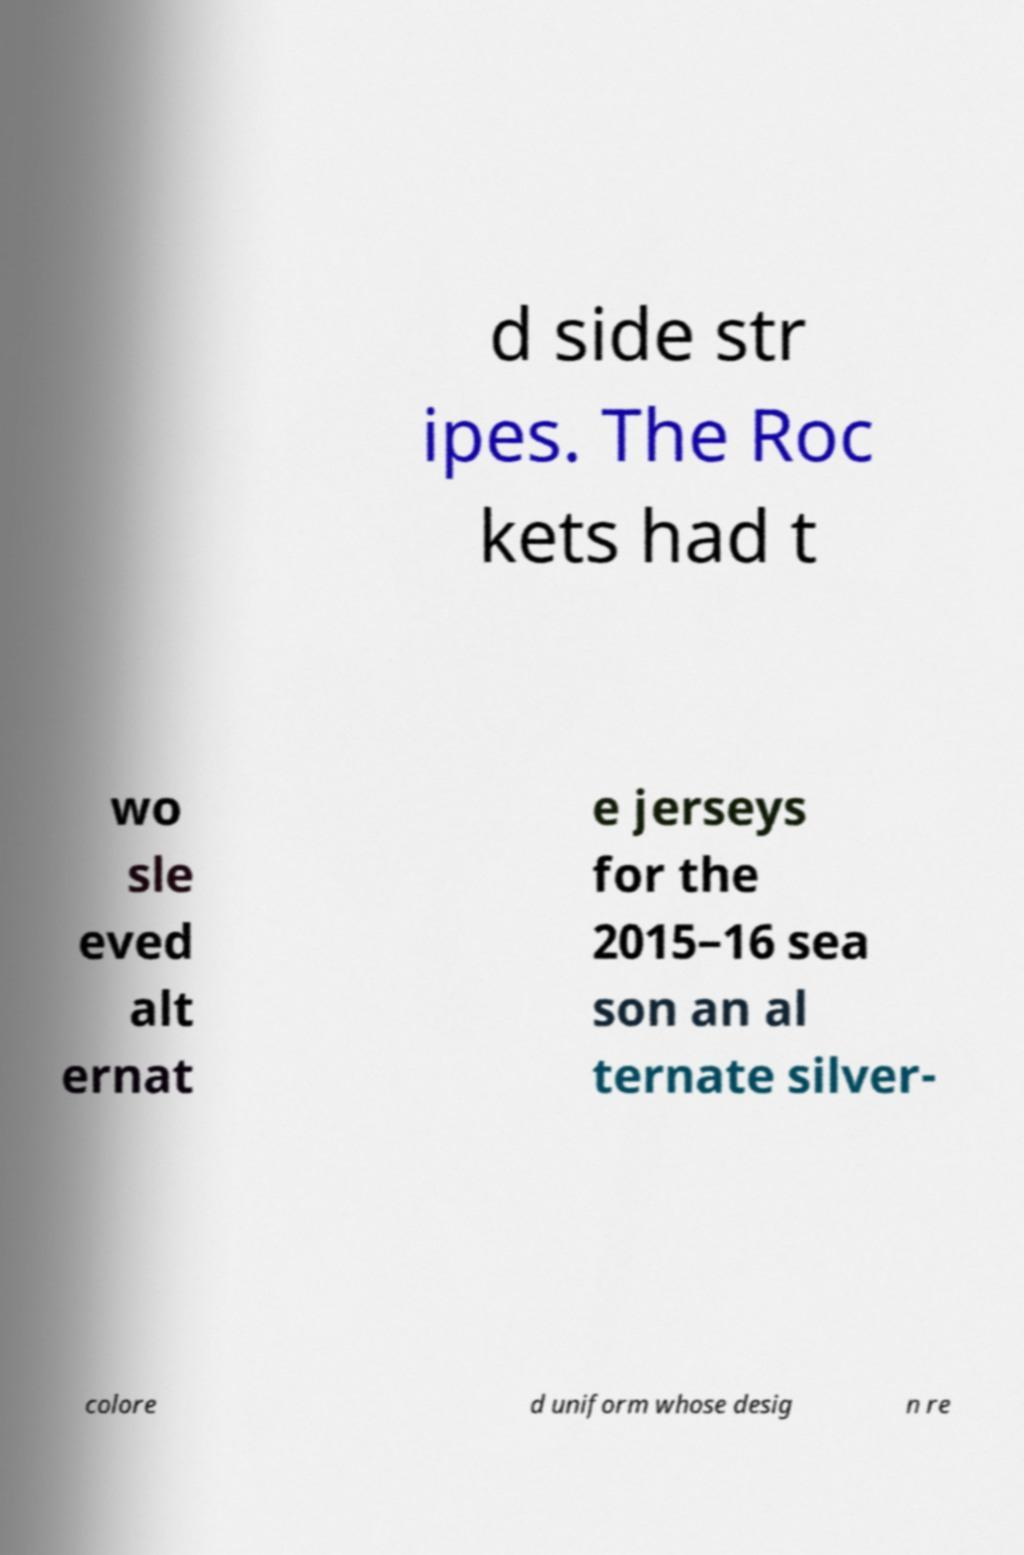I need the written content from this picture converted into text. Can you do that? d side str ipes. The Roc kets had t wo sle eved alt ernat e jerseys for the 2015–16 sea son an al ternate silver- colore d uniform whose desig n re 